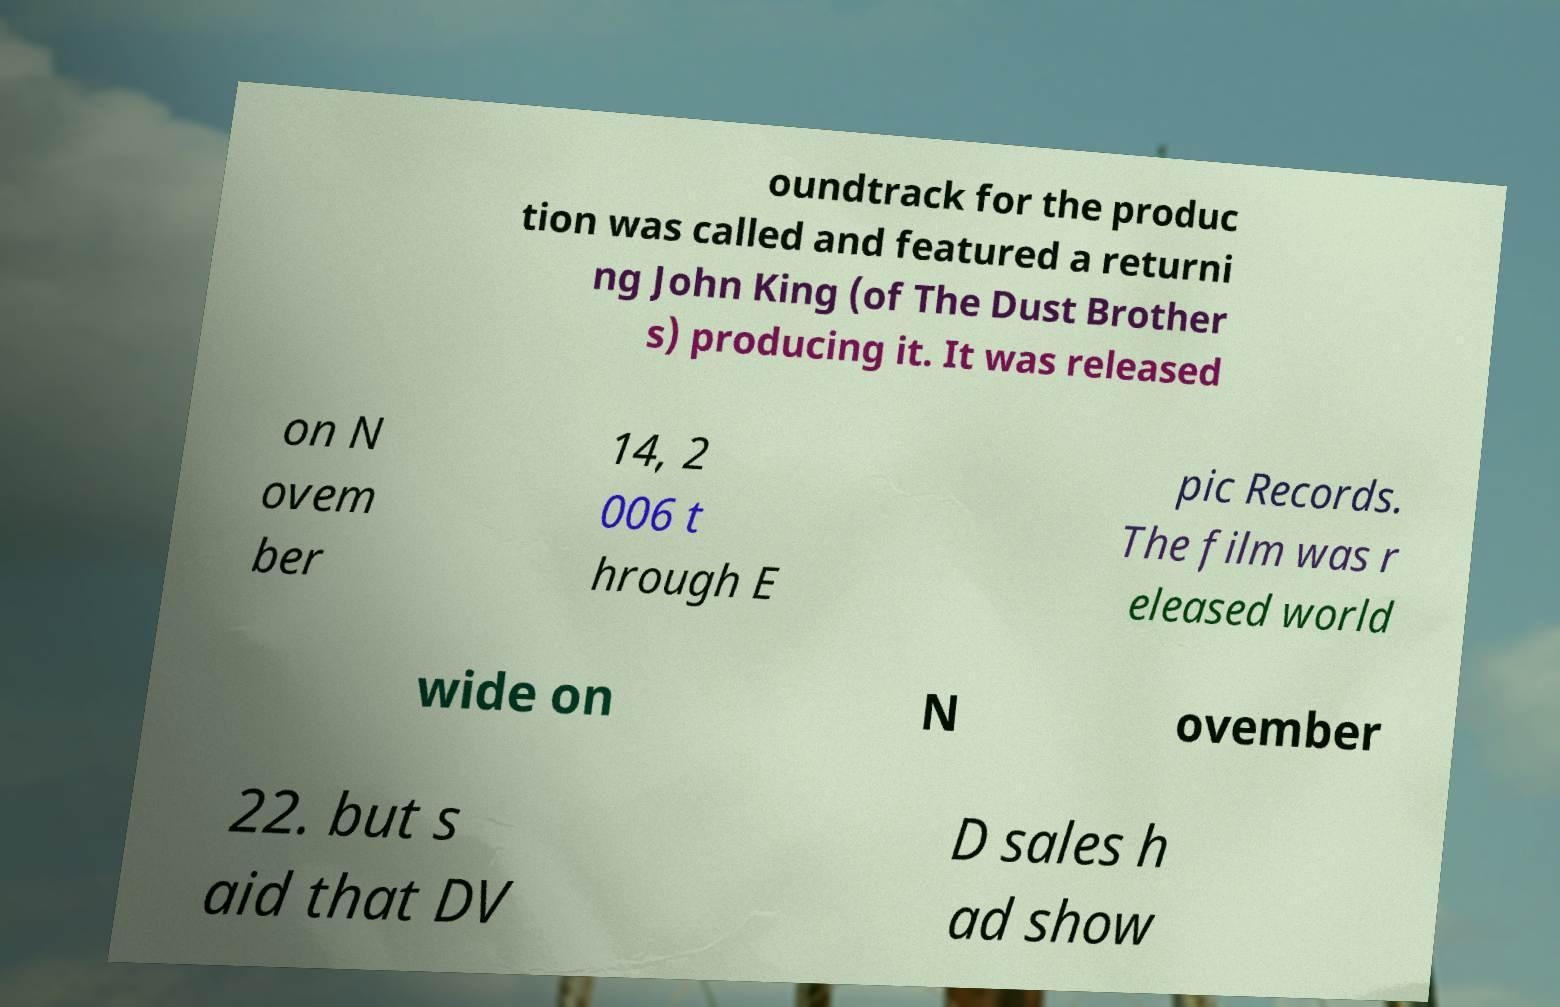Can you accurately transcribe the text from the provided image for me? oundtrack for the produc tion was called and featured a returni ng John King (of The Dust Brother s) producing it. It was released on N ovem ber 14, 2 006 t hrough E pic Records. The film was r eleased world wide on N ovember 22. but s aid that DV D sales h ad show 